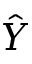<formula> <loc_0><loc_0><loc_500><loc_500>\hat { Y }</formula> 